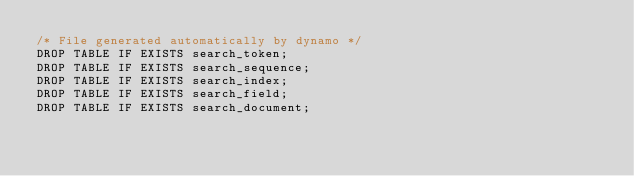Convert code to text. <code><loc_0><loc_0><loc_500><loc_500><_SQL_>/* File generated automatically by dynamo */
DROP TABLE IF EXISTS search_token;
DROP TABLE IF EXISTS search_sequence;
DROP TABLE IF EXISTS search_index;
DROP TABLE IF EXISTS search_field;
DROP TABLE IF EXISTS search_document;
</code> 